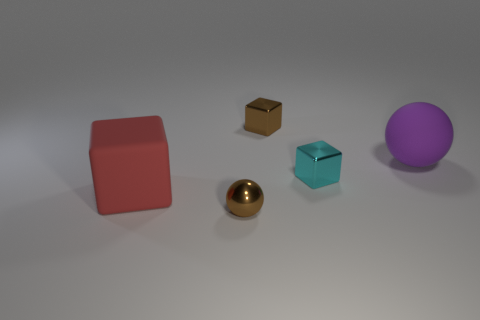The brown metallic object that is right of the metallic object that is in front of the rubber thing that is left of the purple sphere is what shape?
Offer a very short reply. Cube. Is the number of large rubber things less than the number of big yellow balls?
Ensure brevity in your answer.  No. There is a cyan metallic block; are there any small brown metallic things behind it?
Provide a succinct answer. Yes. What shape is the small object that is right of the brown sphere and in front of the big matte sphere?
Make the answer very short. Cube. Are there any green objects that have the same shape as the purple rubber thing?
Make the answer very short. No. Do the rubber object that is left of the cyan cube and the brown shiny object that is in front of the red block have the same size?
Keep it short and to the point. No. Is the number of big green rubber things greater than the number of purple matte things?
Provide a short and direct response. No. What number of other small cubes are the same material as the small cyan cube?
Make the answer very short. 1. Is the cyan thing the same shape as the large red rubber thing?
Ensure brevity in your answer.  Yes. There is a brown metal thing behind the brown thing in front of the brown thing behind the small cyan metallic block; what is its size?
Give a very brief answer. Small. 